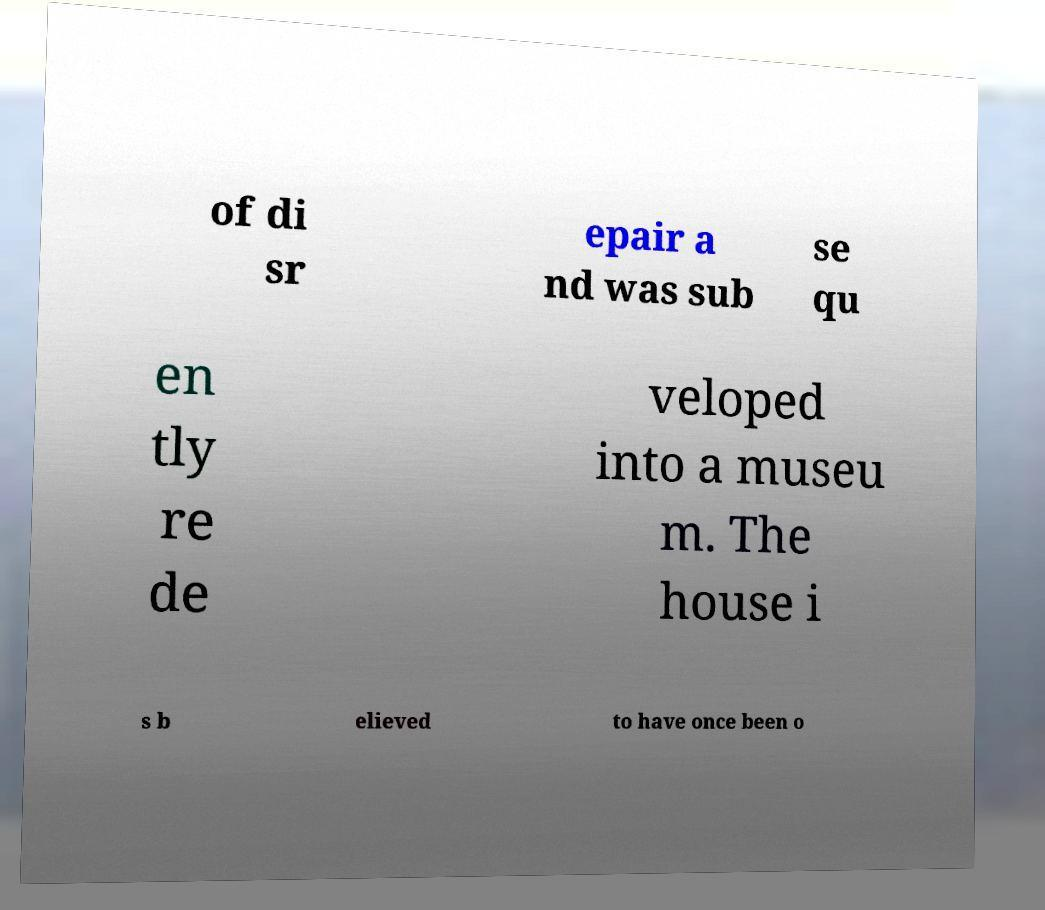There's text embedded in this image that I need extracted. Can you transcribe it verbatim? of di sr epair a nd was sub se qu en tly re de veloped into a museu m. The house i s b elieved to have once been o 